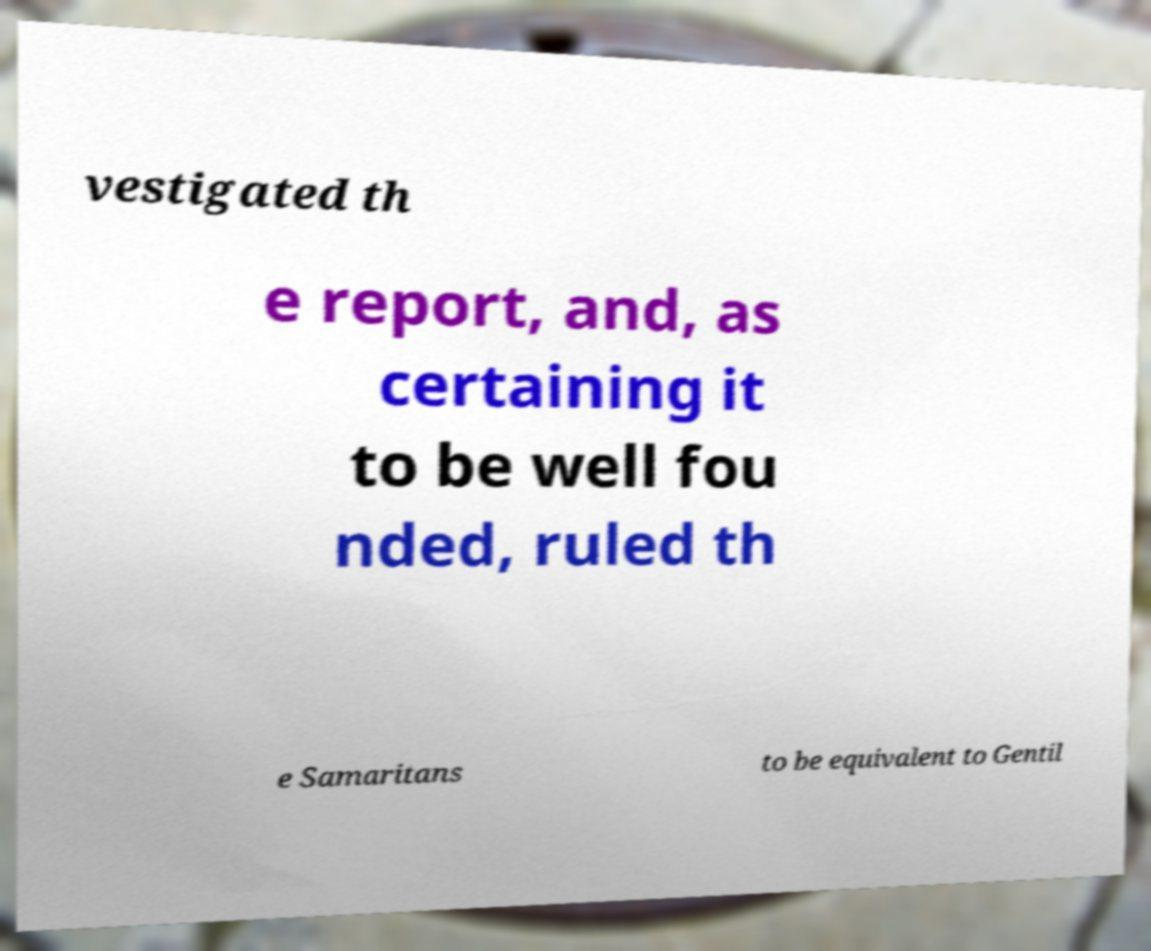For documentation purposes, I need the text within this image transcribed. Could you provide that? vestigated th e report, and, as certaining it to be well fou nded, ruled th e Samaritans to be equivalent to Gentil 